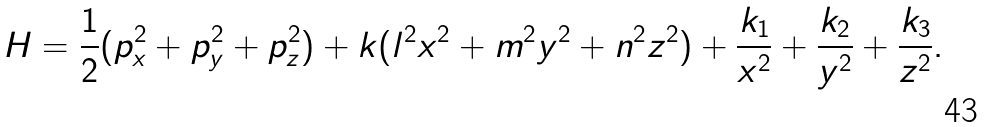Convert formula to latex. <formula><loc_0><loc_0><loc_500><loc_500>H = \frac { 1 } { 2 } ( p _ { x } ^ { 2 } + p _ { y } ^ { 2 } + p _ { z } ^ { 2 } ) + k ( l ^ { 2 } x ^ { 2 } + m ^ { 2 } y ^ { 2 } + n ^ { 2 } z ^ { 2 } ) + \frac { k _ { 1 } } { x ^ { 2 } } + \frac { k _ { 2 } } { y ^ { 2 } } + \frac { k _ { 3 } } { z ^ { 2 } } .</formula> 